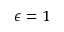<formula> <loc_0><loc_0><loc_500><loc_500>\epsilon = 1</formula> 